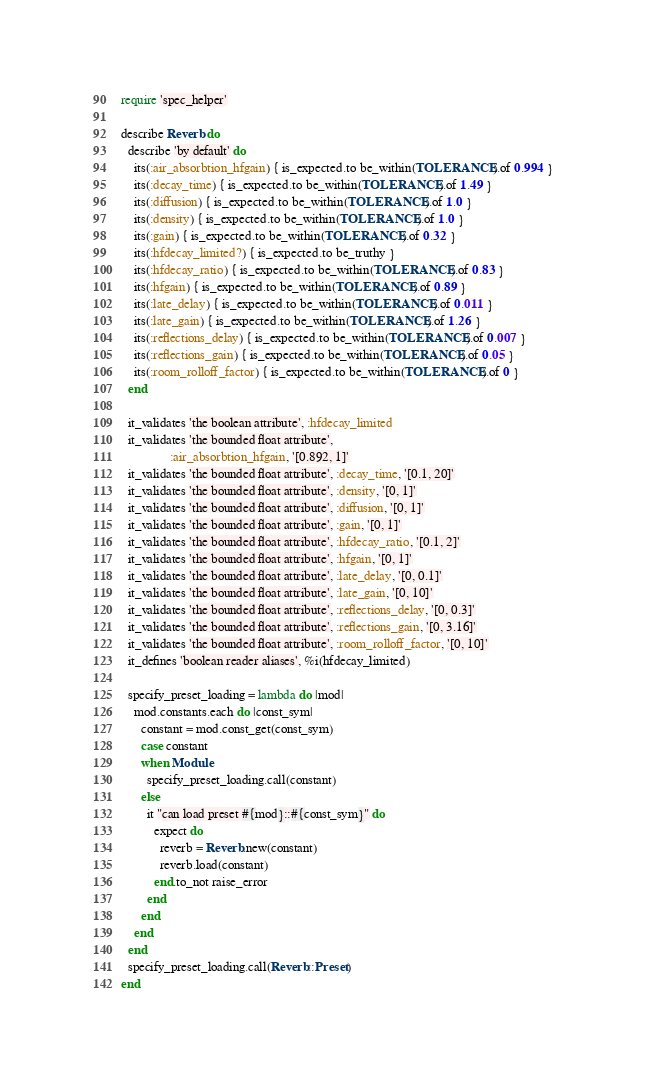<code> <loc_0><loc_0><loc_500><loc_500><_Ruby_>require 'spec_helper'

describe Reverb do
  describe 'by default' do
    its(:air_absorbtion_hfgain) { is_expected.to be_within(TOLERANCE).of 0.994 }
    its(:decay_time) { is_expected.to be_within(TOLERANCE).of 1.49 }
    its(:diffusion) { is_expected.to be_within(TOLERANCE).of 1.0 }
    its(:density) { is_expected.to be_within(TOLERANCE).of 1.0 }
    its(:gain) { is_expected.to be_within(TOLERANCE).of 0.32 }
    its(:hfdecay_limited?) { is_expected.to be_truthy }
    its(:hfdecay_ratio) { is_expected.to be_within(TOLERANCE).of 0.83 }
    its(:hfgain) { is_expected.to be_within(TOLERANCE).of 0.89 }
    its(:late_delay) { is_expected.to be_within(TOLERANCE).of 0.011 }
    its(:late_gain) { is_expected.to be_within(TOLERANCE).of 1.26 }
    its(:reflections_delay) { is_expected.to be_within(TOLERANCE).of 0.007 }
    its(:reflections_gain) { is_expected.to be_within(TOLERANCE).of 0.05 }
    its(:room_rolloff_factor) { is_expected.to be_within(TOLERANCE).of 0 }
  end

  it_validates 'the boolean attribute', :hfdecay_limited
  it_validates 'the bounded float attribute',
               :air_absorbtion_hfgain, '[0.892, 1]'
  it_validates 'the bounded float attribute', :decay_time, '[0.1, 20]'
  it_validates 'the bounded float attribute', :density, '[0, 1]'
  it_validates 'the bounded float attribute', :diffusion, '[0, 1]'
  it_validates 'the bounded float attribute', :gain, '[0, 1]'
  it_validates 'the bounded float attribute', :hfdecay_ratio, '[0.1, 2]'
  it_validates 'the bounded float attribute', :hfgain, '[0, 1]'
  it_validates 'the bounded float attribute', :late_delay, '[0, 0.1]'
  it_validates 'the bounded float attribute', :late_gain, '[0, 10]'
  it_validates 'the bounded float attribute', :reflections_delay, '[0, 0.3]'
  it_validates 'the bounded float attribute', :reflections_gain, '[0, 3.16]'
  it_validates 'the bounded float attribute', :room_rolloff_factor, '[0, 10]'
  it_defines 'boolean reader aliases', %i(hfdecay_limited)

  specify_preset_loading = lambda do |mod|
    mod.constants.each do |const_sym|
      constant = mod.const_get(const_sym)
      case constant
      when Module
        specify_preset_loading.call(constant)
      else
        it "can load preset #{mod}::#{const_sym}" do
          expect do
            reverb = Reverb.new(constant)
            reverb.load(constant)
          end.to_not raise_error
        end
      end
    end
  end
  specify_preset_loading.call(Reverb::Preset)
end
</code> 